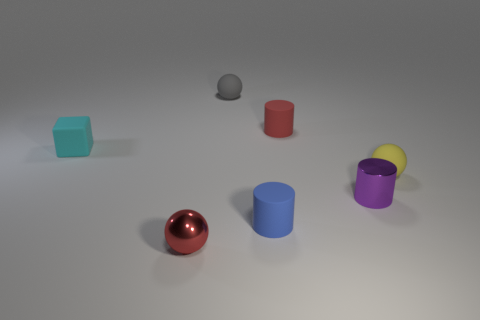Add 3 small red spheres. How many objects exist? 10 Subtract all blocks. How many objects are left? 6 Subtract 1 red cylinders. How many objects are left? 6 Subtract all tiny metal cylinders. Subtract all red metal objects. How many objects are left? 5 Add 1 tiny matte cylinders. How many tiny matte cylinders are left? 3 Add 6 small spheres. How many small spheres exist? 9 